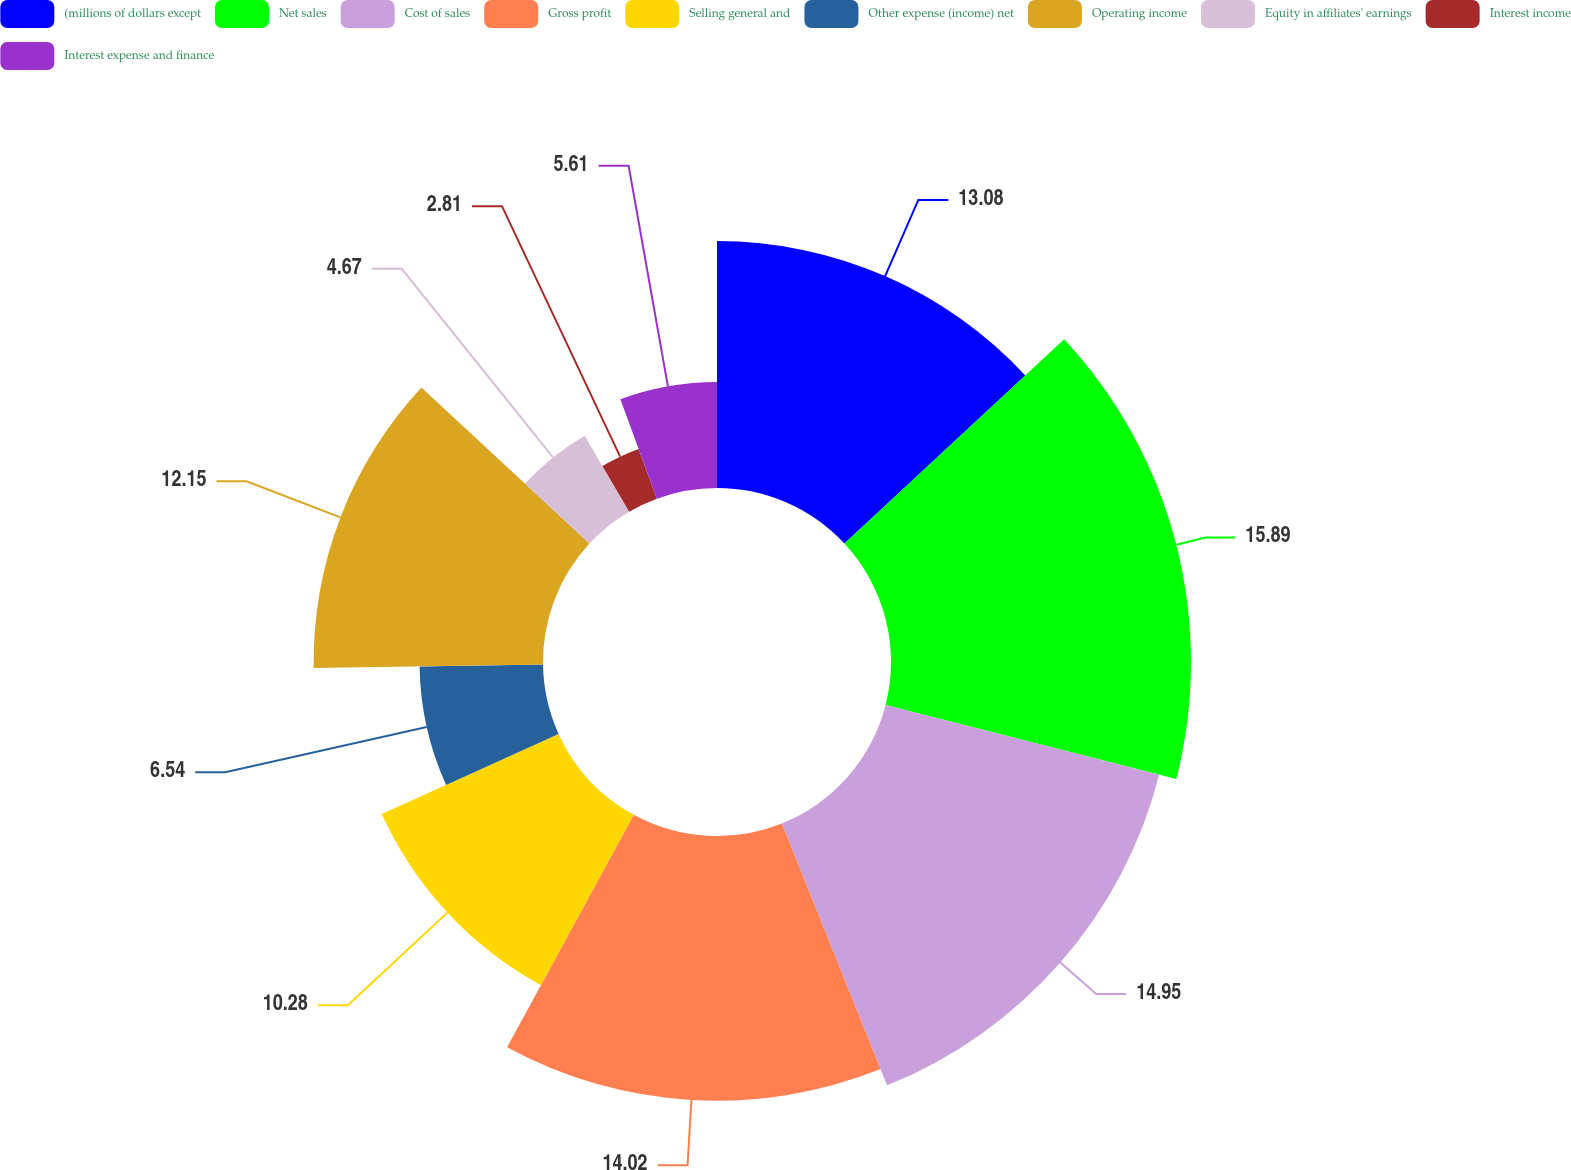Convert chart. <chart><loc_0><loc_0><loc_500><loc_500><pie_chart><fcel>(millions of dollars except<fcel>Net sales<fcel>Cost of sales<fcel>Gross profit<fcel>Selling general and<fcel>Other expense (income) net<fcel>Operating income<fcel>Equity in affiliates' earnings<fcel>Interest income<fcel>Interest expense and finance<nl><fcel>13.08%<fcel>15.89%<fcel>14.95%<fcel>14.02%<fcel>10.28%<fcel>6.54%<fcel>12.15%<fcel>4.67%<fcel>2.81%<fcel>5.61%<nl></chart> 